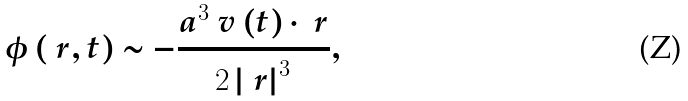<formula> <loc_0><loc_0><loc_500><loc_500>\phi \left ( \ r , t \right ) \sim - \frac { a ^ { 3 } \ v \left ( t \right ) \cdot \ r } { 2 \left | \ r \right | ^ { 3 } } ,</formula> 